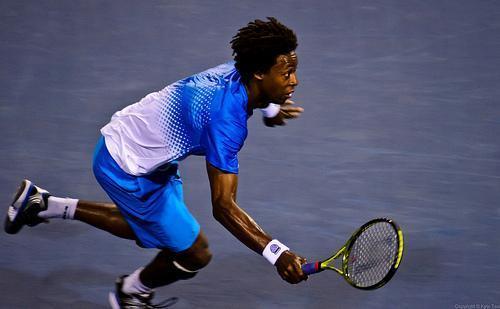How many players are photographed?
Give a very brief answer. 1. How many wristbands are seen?
Give a very brief answer. 2. 